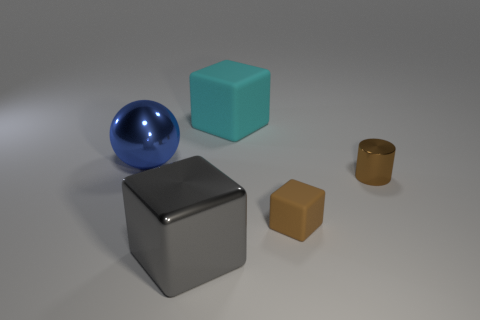There is a object to the right of the brown matte block; what number of matte things are left of it?
Your response must be concise. 2. Is there anything else that has the same color as the metal cylinder?
Offer a very short reply. Yes. How many objects are either big blue shiny balls or brown objects that are on the right side of the small brown rubber block?
Ensure brevity in your answer.  2. What material is the cyan block behind the big shiny thing behind the big block that is in front of the cyan block made of?
Your answer should be very brief. Rubber. There is a sphere that is the same material as the large gray cube; what is its size?
Offer a terse response. Large. What color is the matte object that is to the left of the matte object that is in front of the cyan object?
Your answer should be very brief. Cyan. What number of large blue objects are the same material as the blue ball?
Your answer should be very brief. 0. How many rubber things are big green objects or gray things?
Provide a short and direct response. 0. There is a brown cube that is the same size as the brown shiny cylinder; what is its material?
Provide a succinct answer. Rubber. Is there a cyan cylinder made of the same material as the blue object?
Provide a short and direct response. No. 